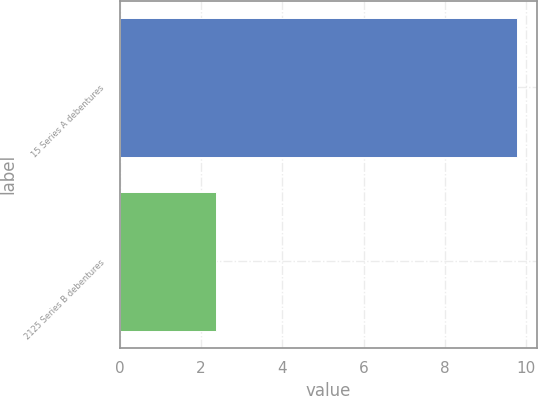<chart> <loc_0><loc_0><loc_500><loc_500><bar_chart><fcel>15 Series A debentures<fcel>2125 Series B debentures<nl><fcel>9.76<fcel>2.36<nl></chart> 